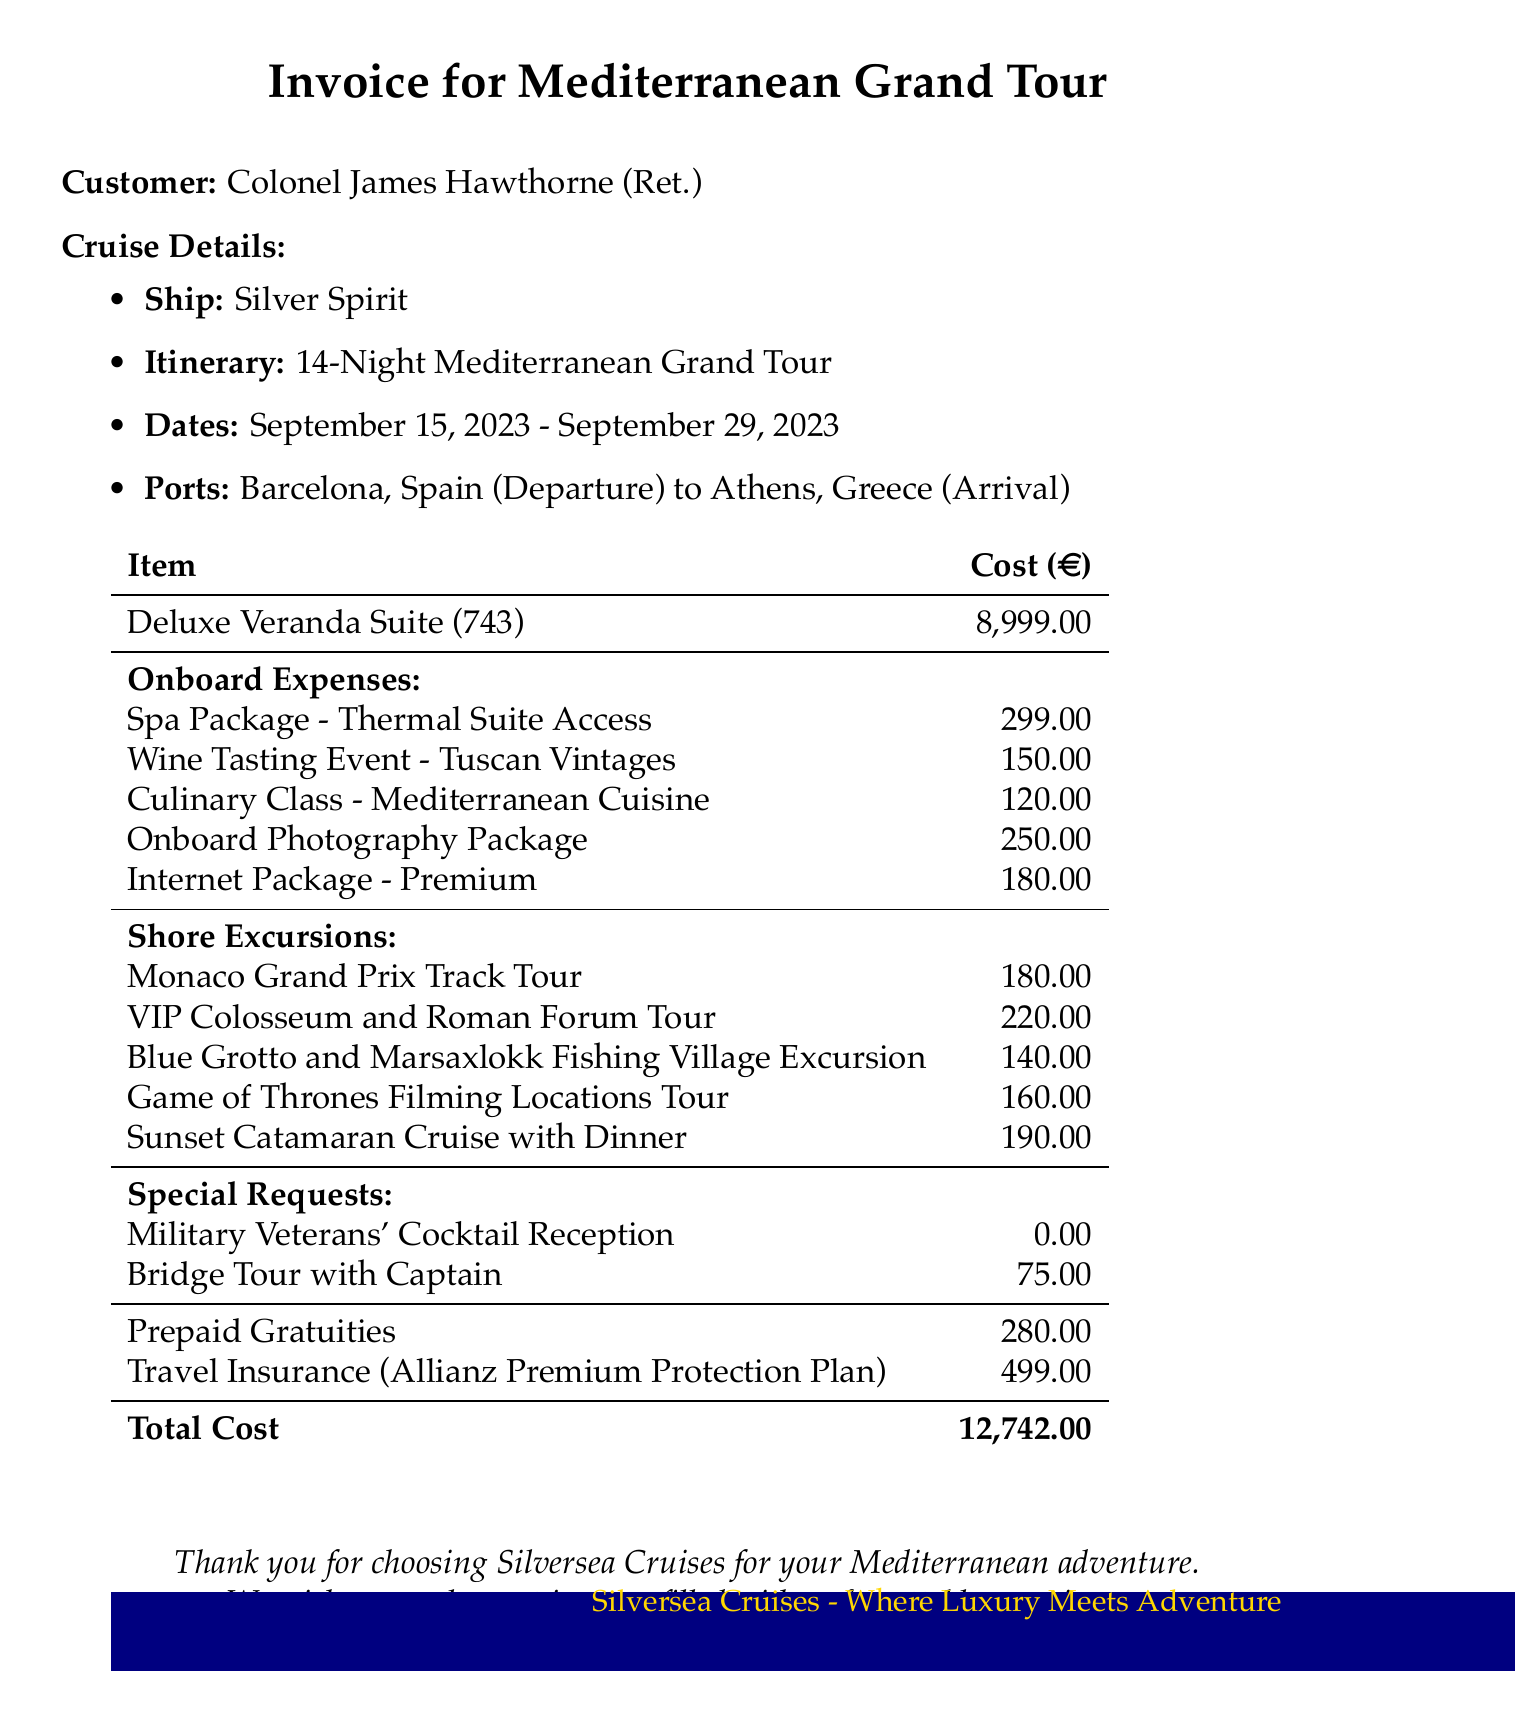What is the invoice number? The invoice number is clearly stated at the top of the document as MED-23-1875.
Answer: MED-23-1875 Who is the customer? The customer name is provided in the document as Colonel James Hawthorne (Ret.).
Answer: Colonel James Hawthorne (Ret.) What is the cost of the Deluxe Veranda Suite? The cost of the stateroom is listed as 8999.00 in the itemized section.
Answer: 8999.00 What is the cost of the Travel Insurance? The cost for Allianz Travel Insurance is indicated as 499.00 in the insurance section.
Answer: 499.00 How many shore excursions are listed? The document contains a total of five shore excursions detailed in the list.
Answer: 5 What was the date of departure? The departure date for the cruise is mentioned in the cruise details as September 15, 2023.
Answer: September 15, 2023 What is the total cost of the invoice? The total cost is summed up at the end of the document as 12742.00.
Answer: 12742.00 What was one of the special requests made? One of the special requests listed is the "Military Veterans' Cocktail Reception," which has a cost of 0.00.
Answer: Military Veterans' Cocktail Reception What was the cost of the Bridge Tour with Captain? The document specifies the cost for the Bridge Tour with Captain as 75.00.
Answer: 75.00 